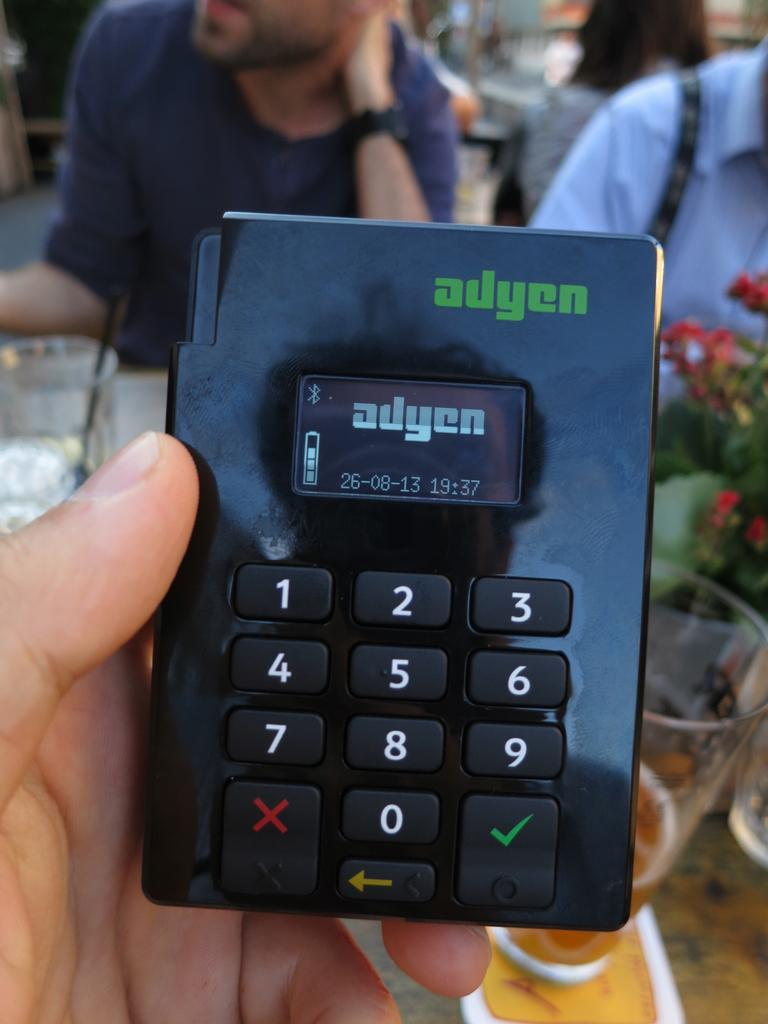Provide a one-sentence caption for the provided image. A device with the brand ayden has a key pad a small screen. 